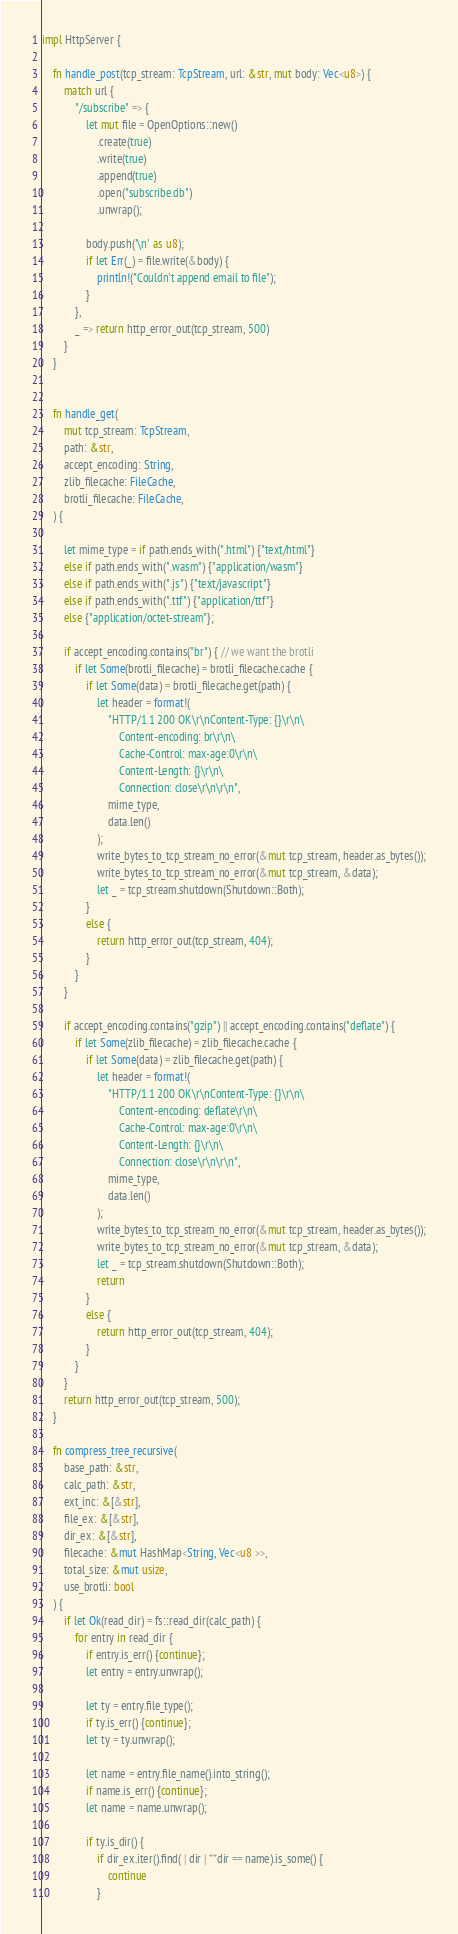Convert code to text. <code><loc_0><loc_0><loc_500><loc_500><_Rust_>
impl HttpServer {
    
    fn handle_post(tcp_stream: TcpStream, url: &str, mut body: Vec<u8>) {
        match url {
            "/subscribe" => {
                let mut file = OpenOptions::new()
                    .create(true)
                    .write(true)
                    .append(true)
                    .open("subscribe.db")
                    .unwrap();
                
                body.push('\n' as u8);
                if let Err(_) = file.write(&body) {
                    println!("Couldn't append email to file");
                }
            },
            _ => return http_error_out(tcp_stream, 500)
        }
    }
    
    
    fn handle_get(
        mut tcp_stream: TcpStream,
        path: &str,
        accept_encoding: String,
        zlib_filecache: FileCache,
        brotli_filecache: FileCache,
    ) {
        
        let mime_type = if path.ends_with(".html") {"text/html"}
        else if path.ends_with(".wasm") {"application/wasm"}
        else if path.ends_with(".js") {"text/javascript"}
        else if path.ends_with(".ttf") {"application/ttf"}
        else {"application/octet-stream"};
        
        if accept_encoding.contains("br") { // we want the brotli
            if let Some(brotli_filecache) = brotli_filecache.cache {
                if let Some(data) = brotli_filecache.get(path) {
                    let header = format!(
                        "HTTP/1.1 200 OK\r\nContent-Type: {}\r\n\
                            Content-encoding: br\r\n\
                            Cache-Control: max-age:0\r\n\
                            Content-Length: {}\r\n\
                            Connection: close\r\n\r\n",
                        mime_type,
                        data.len()
                    );
                    write_bytes_to_tcp_stream_no_error(&mut tcp_stream, header.as_bytes());
                    write_bytes_to_tcp_stream_no_error(&mut tcp_stream, &data);
                    let _ = tcp_stream.shutdown(Shutdown::Both);
                }
                else {
                    return http_error_out(tcp_stream, 404);
                }
            }
        }
        
        if accept_encoding.contains("gzip") || accept_encoding.contains("deflate") {
            if let Some(zlib_filecache) = zlib_filecache.cache {
                if let Some(data) = zlib_filecache.get(path) {
                    let header = format!(
                        "HTTP/1.1 200 OK\r\nContent-Type: {}\r\n\
                            Content-encoding: deflate\r\n\
                            Cache-Control: max-age:0\r\n\
                            Content-Length: {}\r\n\
                            Connection: close\r\n\r\n",
                        mime_type,
                        data.len()
                    );
                    write_bytes_to_tcp_stream_no_error(&mut tcp_stream, header.as_bytes());
                    write_bytes_to_tcp_stream_no_error(&mut tcp_stream, &data);
                    let _ = tcp_stream.shutdown(Shutdown::Both);
                    return
                }
                else {
                    return http_error_out(tcp_stream, 404);
                }
            }
        }
        return http_error_out(tcp_stream, 500);
    }
    
    fn compress_tree_recursive(
        base_path: &str,
        calc_path: &str,
        ext_inc: &[&str],
        file_ex: &[&str],
        dir_ex: &[&str],
        filecache: &mut HashMap<String, Vec<u8 >>,
        total_size: &mut usize,
        use_brotli: bool
    ) {
        if let Ok(read_dir) = fs::read_dir(calc_path) {
            for entry in read_dir {
                if entry.is_err() {continue};
                let entry = entry.unwrap();
                
                let ty = entry.file_type();
                if ty.is_err() {continue};
                let ty = ty.unwrap();
                
                let name = entry.file_name().into_string();
                if name.is_err() {continue};
                let name = name.unwrap();
                
                if ty.is_dir() {
                    if dir_ex.iter().find( | dir | **dir == name).is_some() {
                        continue
                    }</code> 